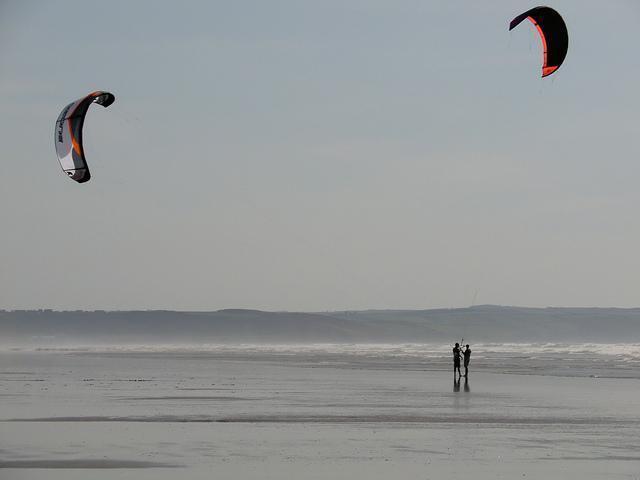How many people are visible?
Give a very brief answer. 2. How many people are in the water?
Give a very brief answer. 2. How many blue train cars are there?
Give a very brief answer. 0. 